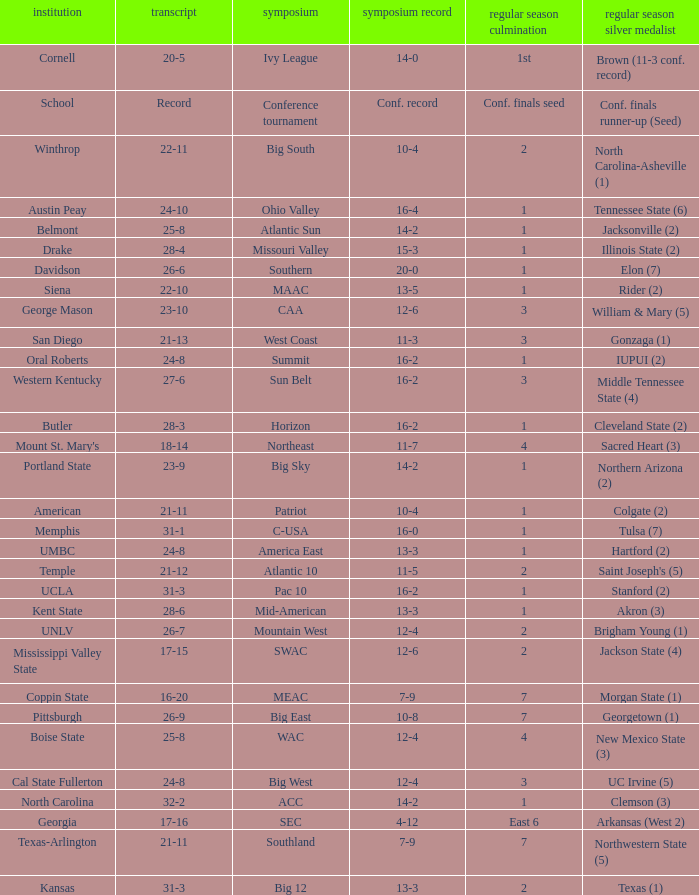What was the overall record of Oral Roberts college? 24-8. Would you be able to parse every entry in this table? {'header': ['institution', 'transcript', 'symposium', 'symposium record', 'regular season culmination', 'regular season silver medalist'], 'rows': [['Cornell', '20-5', 'Ivy League', '14-0', '1st', 'Brown (11-3 conf. record)'], ['School', 'Record', 'Conference tournament', 'Conf. record', 'Conf. finals seed', 'Conf. finals runner-up (Seed)'], ['Winthrop', '22-11', 'Big South', '10-4', '2', 'North Carolina-Asheville (1)'], ['Austin Peay', '24-10', 'Ohio Valley', '16-4', '1', 'Tennessee State (6)'], ['Belmont', '25-8', 'Atlantic Sun', '14-2', '1', 'Jacksonville (2)'], ['Drake', '28-4', 'Missouri Valley', '15-3', '1', 'Illinois State (2)'], ['Davidson', '26-6', 'Southern', '20-0', '1', 'Elon (7)'], ['Siena', '22-10', 'MAAC', '13-5', '1', 'Rider (2)'], ['George Mason', '23-10', 'CAA', '12-6', '3', 'William & Mary (5)'], ['San Diego', '21-13', 'West Coast', '11-3', '3', 'Gonzaga (1)'], ['Oral Roberts', '24-8', 'Summit', '16-2', '1', 'IUPUI (2)'], ['Western Kentucky', '27-6', 'Sun Belt', '16-2', '3', 'Middle Tennessee State (4)'], ['Butler', '28-3', 'Horizon', '16-2', '1', 'Cleveland State (2)'], ["Mount St. Mary's", '18-14', 'Northeast', '11-7', '4', 'Sacred Heart (3)'], ['Portland State', '23-9', 'Big Sky', '14-2', '1', 'Northern Arizona (2)'], ['American', '21-11', 'Patriot', '10-4', '1', 'Colgate (2)'], ['Memphis', '31-1', 'C-USA', '16-0', '1', 'Tulsa (7)'], ['UMBC', '24-8', 'America East', '13-3', '1', 'Hartford (2)'], ['Temple', '21-12', 'Atlantic 10', '11-5', '2', "Saint Joseph's (5)"], ['UCLA', '31-3', 'Pac 10', '16-2', '1', 'Stanford (2)'], ['Kent State', '28-6', 'Mid-American', '13-3', '1', 'Akron (3)'], ['UNLV', '26-7', 'Mountain West', '12-4', '2', 'Brigham Young (1)'], ['Mississippi Valley State', '17-15', 'SWAC', '12-6', '2', 'Jackson State (4)'], ['Coppin State', '16-20', 'MEAC', '7-9', '7', 'Morgan State (1)'], ['Pittsburgh', '26-9', 'Big East', '10-8', '7', 'Georgetown (1)'], ['Boise State', '25-8', 'WAC', '12-4', '4', 'New Mexico State (3)'], ['Cal State Fullerton', '24-8', 'Big West', '12-4', '3', 'UC Irvine (5)'], ['North Carolina', '32-2', 'ACC', '14-2', '1', 'Clemson (3)'], ['Georgia', '17-16', 'SEC', '4-12', 'East 6', 'Arkansas (West 2)'], ['Texas-Arlington', '21-11', 'Southland', '7-9', '7', 'Northwestern State (5)'], ['Kansas', '31-3', 'Big 12', '13-3', '2', 'Texas (1)']]} 